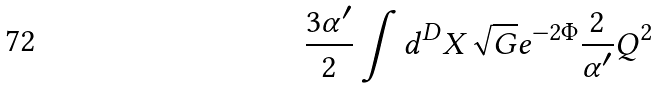<formula> <loc_0><loc_0><loc_500><loc_500>\frac { 3 \alpha ^ { \prime } } { 2 } \int d ^ { D } X \sqrt { G } e ^ { - 2 \Phi } \frac { 2 } { \alpha ^ { \prime } } Q ^ { 2 }</formula> 